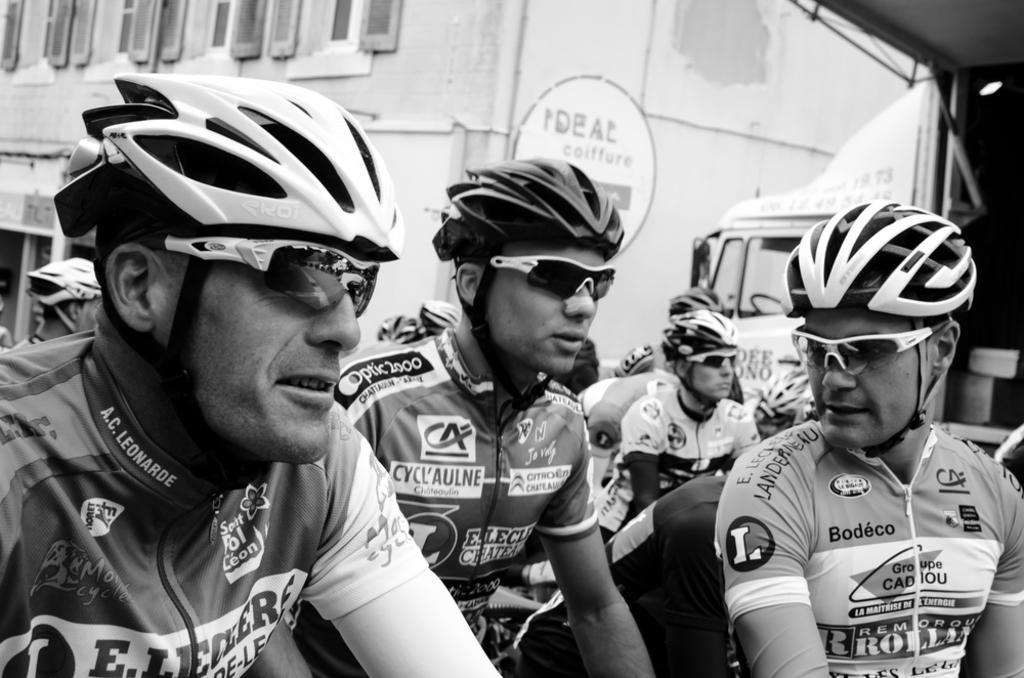Describe this image in one or two sentences. In the image we can see the black and white picture of people wearing clothes, goggles and helmets. Here we can see the vehicle, building and windows of the building. 